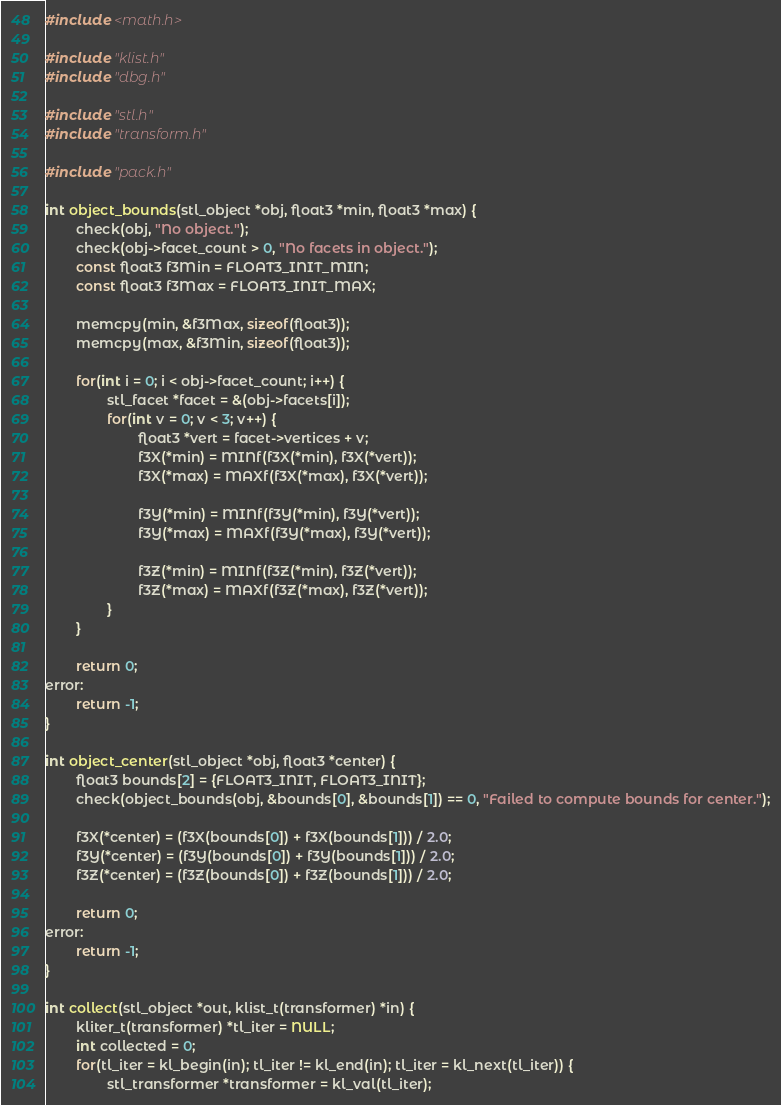<code> <loc_0><loc_0><loc_500><loc_500><_C_>#include <math.h>

#include "klist.h"
#include "dbg.h"

#include "stl.h"
#include "transform.h"

#include "pack.h"

int object_bounds(stl_object *obj, float3 *min, float3 *max) {
		check(obj, "No object.");
		check(obj->facet_count > 0, "No facets in object.");
		const float3 f3Min = FLOAT3_INIT_MIN;
		const float3 f3Max = FLOAT3_INIT_MAX;

		memcpy(min, &f3Max, sizeof(float3));
		memcpy(max, &f3Min, sizeof(float3));

		for(int i = 0; i < obj->facet_count; i++) {
				stl_facet *facet = &(obj->facets[i]);
				for(int v = 0; v < 3; v++) {
						float3 *vert = facet->vertices + v;
						f3X(*min) = MINf(f3X(*min), f3X(*vert));
						f3X(*max) = MAXf(f3X(*max), f3X(*vert));

						f3Y(*min) = MINf(f3Y(*min), f3Y(*vert));
						f3Y(*max) = MAXf(f3Y(*max), f3Y(*vert));

						f3Z(*min) = MINf(f3Z(*min), f3Z(*vert));
						f3Z(*max) = MAXf(f3Z(*max), f3Z(*vert));
				}
		}

		return 0;
error:
		return -1;
}

int object_center(stl_object *obj, float3 *center) {
		float3 bounds[2] = {FLOAT3_INIT, FLOAT3_INIT};
		check(object_bounds(obj, &bounds[0], &bounds[1]) == 0, "Failed to compute bounds for center.");

		f3X(*center) = (f3X(bounds[0]) + f3X(bounds[1])) / 2.0;
		f3Y(*center) = (f3Y(bounds[0]) + f3Y(bounds[1])) / 2.0;
		f3Z(*center) = (f3Z(bounds[0]) + f3Z(bounds[1])) / 2.0;

		return 0;
error:
		return -1;
}

int collect(stl_object *out, klist_t(transformer) *in) {
		kliter_t(transformer) *tl_iter = NULL;
		int collected = 0;
		for(tl_iter = kl_begin(in); tl_iter != kl_end(in); tl_iter = kl_next(tl_iter)) {
				stl_transformer *transformer = kl_val(tl_iter);</code> 